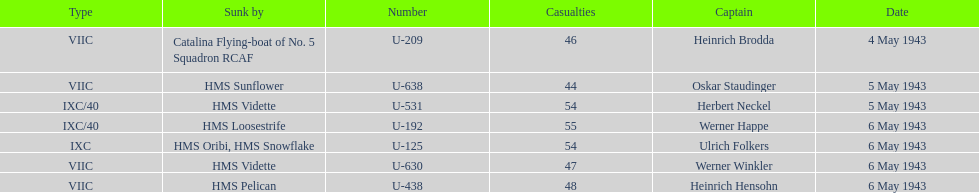How many more casualties occurred on may 6 compared to may 4? 158. 